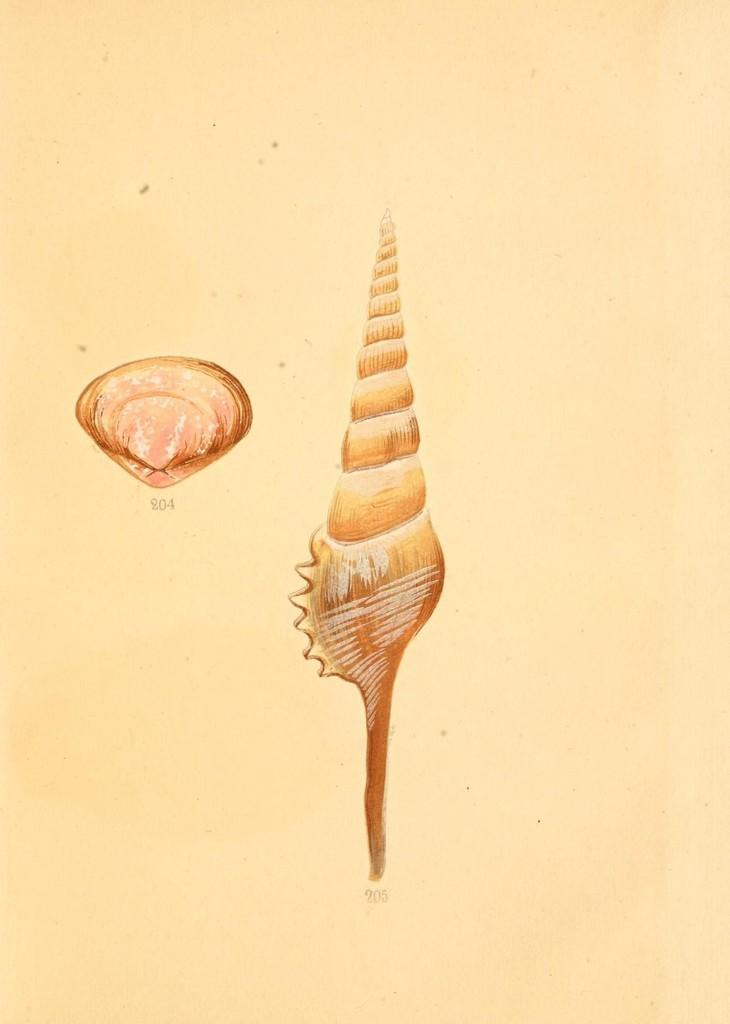What can be seen in the image? There is a poster in the image. What news is being reported on the poster in the image? There is no news being reported on the poster in the image, as the provided facts only mention the presence of a poster without any specific details about its content. 